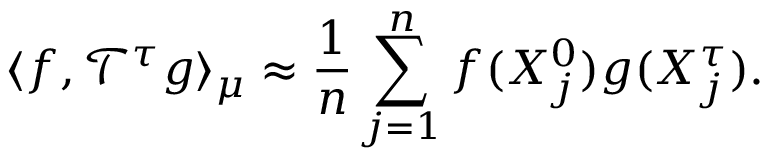<formula> <loc_0><loc_0><loc_500><loc_500>\langle f , \mathcal { T } ^ { \tau } g \rangle _ { \mu } \approx \frac { 1 } { n } \sum _ { j = 1 } ^ { n } f ( X _ { j } ^ { 0 } ) g ( X _ { j } ^ { \tau } ) .</formula> 